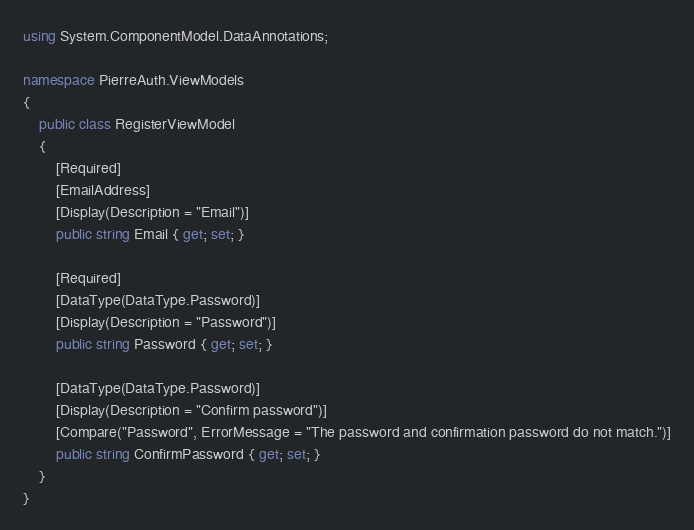<code> <loc_0><loc_0><loc_500><loc_500><_C#_>using System.ComponentModel.DataAnnotations;

namespace PierreAuth.ViewModels
{
    public class RegisterViewModel
    {
        [Required]
        [EmailAddress]
        [Display(Description = "Email")]
        public string Email { get; set; }

        [Required]
        [DataType(DataType.Password)]
        [Display(Description = "Password")]
        public string Password { get; set; }

        [DataType(DataType.Password)]
        [Display(Description = "Confirm password")]
        [Compare("Password", ErrorMessage = "The password and confirmation password do not match.")]
        public string ConfirmPassword { get; set; }
    }
}</code> 